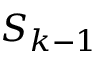<formula> <loc_0><loc_0><loc_500><loc_500>S _ { k - 1 }</formula> 